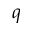<formula> <loc_0><loc_0><loc_500><loc_500>q</formula> 